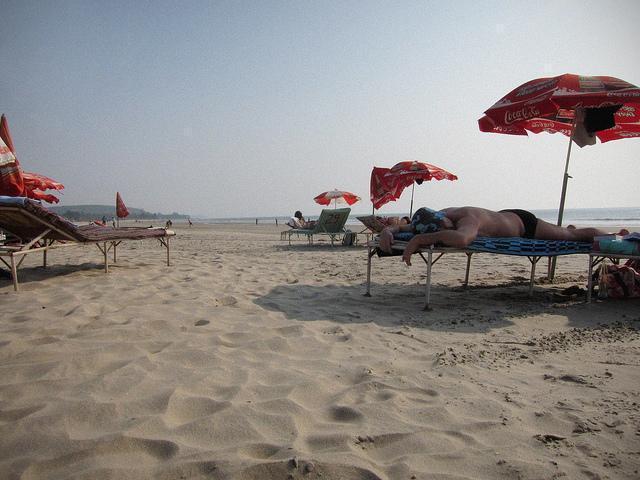The man lying down uses the umbrella for what?
Select the correct answer and articulate reasoning with the following format: 'Answer: answer
Rationale: rationale.'
Options: Rain protection, signaling, shade, advertising. Answer: shade.
Rationale: The man wants shade. 